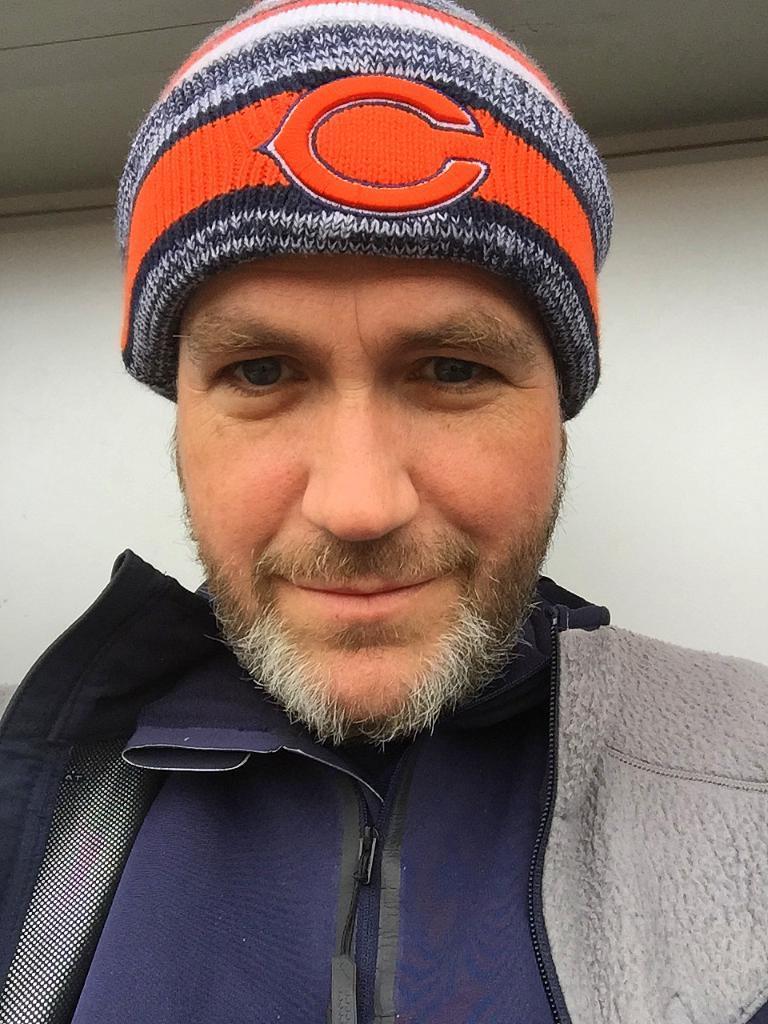Describe this image in one or two sentences. In this picture I can see a man, he is wearing a cap on his head and a wall in the background. 